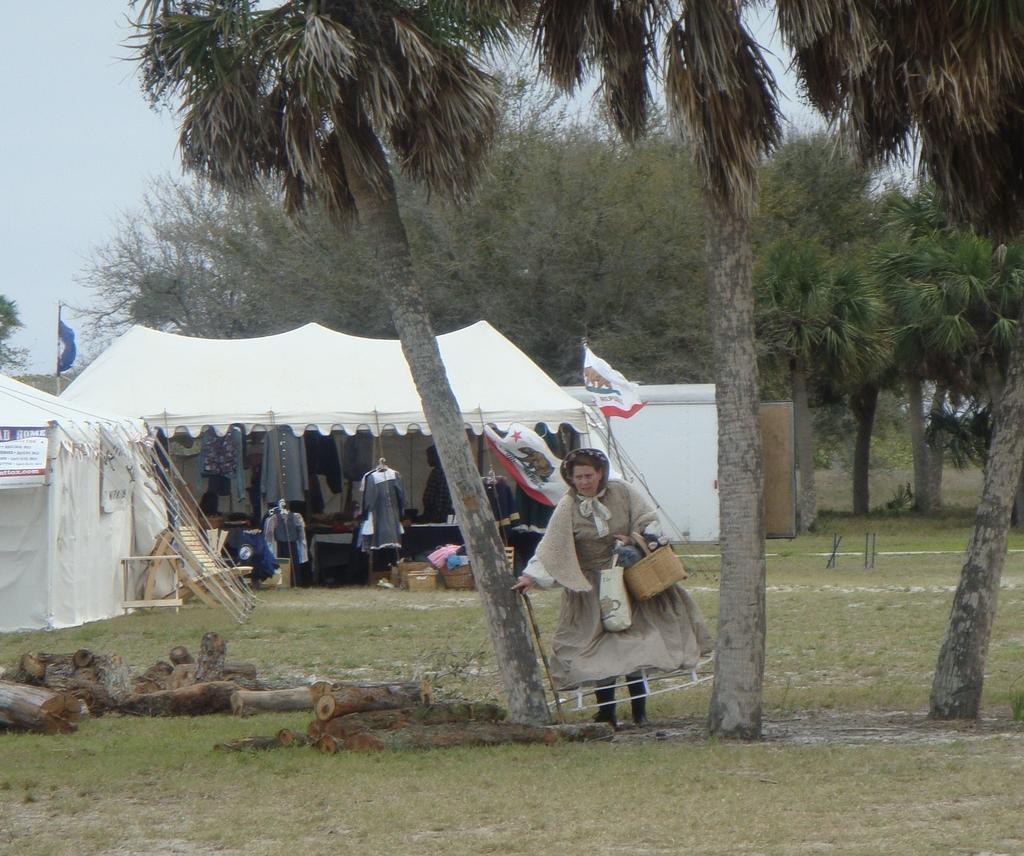Could you give a brief overview of what you see in this image? In the image there is a woman in gown walking in between two trees on a grass land, in the back there is tent with clothes inside it and there are many trees in the background and above its sky. 